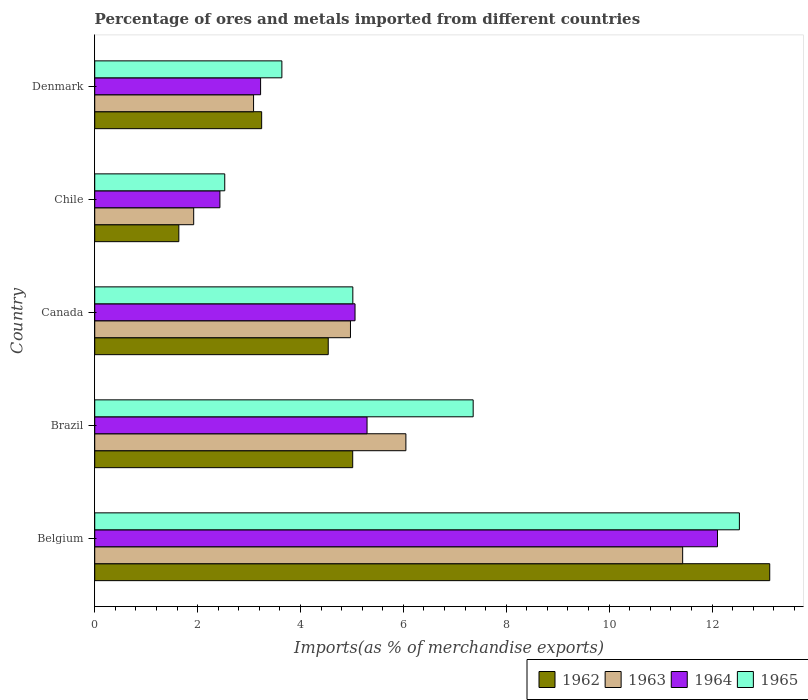How many groups of bars are there?
Ensure brevity in your answer.  5. How many bars are there on the 1st tick from the bottom?
Your answer should be compact. 4. What is the label of the 1st group of bars from the top?
Ensure brevity in your answer.  Denmark. What is the percentage of imports to different countries in 1965 in Canada?
Provide a succinct answer. 5.02. Across all countries, what is the maximum percentage of imports to different countries in 1963?
Provide a short and direct response. 11.43. Across all countries, what is the minimum percentage of imports to different countries in 1963?
Your response must be concise. 1.92. What is the total percentage of imports to different countries in 1965 in the graph?
Make the answer very short. 31.07. What is the difference between the percentage of imports to different countries in 1965 in Belgium and that in Canada?
Provide a short and direct response. 7.51. What is the difference between the percentage of imports to different countries in 1965 in Denmark and the percentage of imports to different countries in 1963 in Canada?
Keep it short and to the point. -1.33. What is the average percentage of imports to different countries in 1962 per country?
Offer a terse response. 5.51. What is the difference between the percentage of imports to different countries in 1963 and percentage of imports to different countries in 1964 in Belgium?
Provide a short and direct response. -0.68. In how many countries, is the percentage of imports to different countries in 1963 greater than 6.4 %?
Offer a terse response. 1. What is the ratio of the percentage of imports to different countries in 1962 in Brazil to that in Chile?
Provide a succinct answer. 3.07. Is the percentage of imports to different countries in 1962 in Canada less than that in Denmark?
Give a very brief answer. No. Is the difference between the percentage of imports to different countries in 1963 in Belgium and Denmark greater than the difference between the percentage of imports to different countries in 1964 in Belgium and Denmark?
Offer a very short reply. No. What is the difference between the highest and the second highest percentage of imports to different countries in 1962?
Provide a succinct answer. 8.11. What is the difference between the highest and the lowest percentage of imports to different countries in 1964?
Provide a short and direct response. 9.67. Is the sum of the percentage of imports to different countries in 1965 in Canada and Chile greater than the maximum percentage of imports to different countries in 1962 across all countries?
Keep it short and to the point. No. What does the 4th bar from the top in Denmark represents?
Your answer should be compact. 1962. What does the 3rd bar from the bottom in Chile represents?
Your response must be concise. 1964. Are all the bars in the graph horizontal?
Provide a succinct answer. Yes. How many countries are there in the graph?
Offer a terse response. 5. What is the difference between two consecutive major ticks on the X-axis?
Offer a terse response. 2. Are the values on the major ticks of X-axis written in scientific E-notation?
Your answer should be compact. No. Does the graph contain any zero values?
Give a very brief answer. No. Does the graph contain grids?
Provide a short and direct response. No. How are the legend labels stacked?
Your answer should be very brief. Horizontal. What is the title of the graph?
Your answer should be compact. Percentage of ores and metals imported from different countries. Does "2002" appear as one of the legend labels in the graph?
Give a very brief answer. No. What is the label or title of the X-axis?
Give a very brief answer. Imports(as % of merchandise exports). What is the Imports(as % of merchandise exports) of 1962 in Belgium?
Ensure brevity in your answer.  13.12. What is the Imports(as % of merchandise exports) in 1963 in Belgium?
Your answer should be very brief. 11.43. What is the Imports(as % of merchandise exports) in 1964 in Belgium?
Give a very brief answer. 12.11. What is the Imports(as % of merchandise exports) in 1965 in Belgium?
Make the answer very short. 12.53. What is the Imports(as % of merchandise exports) of 1962 in Brazil?
Make the answer very short. 5.01. What is the Imports(as % of merchandise exports) in 1963 in Brazil?
Keep it short and to the point. 6.05. What is the Imports(as % of merchandise exports) in 1964 in Brazil?
Provide a succinct answer. 5.29. What is the Imports(as % of merchandise exports) of 1965 in Brazil?
Provide a succinct answer. 7.36. What is the Imports(as % of merchandise exports) of 1962 in Canada?
Provide a short and direct response. 4.54. What is the Imports(as % of merchandise exports) of 1963 in Canada?
Provide a succinct answer. 4.97. What is the Imports(as % of merchandise exports) of 1964 in Canada?
Give a very brief answer. 5.06. What is the Imports(as % of merchandise exports) of 1965 in Canada?
Keep it short and to the point. 5.02. What is the Imports(as % of merchandise exports) in 1962 in Chile?
Ensure brevity in your answer.  1.63. What is the Imports(as % of merchandise exports) of 1963 in Chile?
Offer a very short reply. 1.92. What is the Imports(as % of merchandise exports) of 1964 in Chile?
Keep it short and to the point. 2.43. What is the Imports(as % of merchandise exports) in 1965 in Chile?
Keep it short and to the point. 2.53. What is the Imports(as % of merchandise exports) in 1962 in Denmark?
Your answer should be very brief. 3.25. What is the Imports(as % of merchandise exports) in 1963 in Denmark?
Ensure brevity in your answer.  3.09. What is the Imports(as % of merchandise exports) in 1964 in Denmark?
Give a very brief answer. 3.22. What is the Imports(as % of merchandise exports) in 1965 in Denmark?
Make the answer very short. 3.64. Across all countries, what is the maximum Imports(as % of merchandise exports) in 1962?
Your response must be concise. 13.12. Across all countries, what is the maximum Imports(as % of merchandise exports) in 1963?
Provide a short and direct response. 11.43. Across all countries, what is the maximum Imports(as % of merchandise exports) in 1964?
Your answer should be compact. 12.11. Across all countries, what is the maximum Imports(as % of merchandise exports) in 1965?
Provide a succinct answer. 12.53. Across all countries, what is the minimum Imports(as % of merchandise exports) in 1962?
Offer a terse response. 1.63. Across all countries, what is the minimum Imports(as % of merchandise exports) of 1963?
Give a very brief answer. 1.92. Across all countries, what is the minimum Imports(as % of merchandise exports) in 1964?
Give a very brief answer. 2.43. Across all countries, what is the minimum Imports(as % of merchandise exports) of 1965?
Provide a succinct answer. 2.53. What is the total Imports(as % of merchandise exports) of 1962 in the graph?
Make the answer very short. 27.56. What is the total Imports(as % of merchandise exports) of 1963 in the graph?
Make the answer very short. 27.46. What is the total Imports(as % of merchandise exports) in 1964 in the graph?
Keep it short and to the point. 28.12. What is the total Imports(as % of merchandise exports) in 1965 in the graph?
Your answer should be very brief. 31.07. What is the difference between the Imports(as % of merchandise exports) of 1962 in Belgium and that in Brazil?
Your response must be concise. 8.11. What is the difference between the Imports(as % of merchandise exports) in 1963 in Belgium and that in Brazil?
Provide a short and direct response. 5.38. What is the difference between the Imports(as % of merchandise exports) of 1964 in Belgium and that in Brazil?
Your answer should be compact. 6.81. What is the difference between the Imports(as % of merchandise exports) in 1965 in Belgium and that in Brazil?
Your answer should be compact. 5.18. What is the difference between the Imports(as % of merchandise exports) of 1962 in Belgium and that in Canada?
Offer a terse response. 8.58. What is the difference between the Imports(as % of merchandise exports) in 1963 in Belgium and that in Canada?
Make the answer very short. 6.46. What is the difference between the Imports(as % of merchandise exports) in 1964 in Belgium and that in Canada?
Give a very brief answer. 7.05. What is the difference between the Imports(as % of merchandise exports) of 1965 in Belgium and that in Canada?
Ensure brevity in your answer.  7.51. What is the difference between the Imports(as % of merchandise exports) in 1962 in Belgium and that in Chile?
Your answer should be compact. 11.49. What is the difference between the Imports(as % of merchandise exports) of 1963 in Belgium and that in Chile?
Ensure brevity in your answer.  9.51. What is the difference between the Imports(as % of merchandise exports) of 1964 in Belgium and that in Chile?
Provide a short and direct response. 9.67. What is the difference between the Imports(as % of merchandise exports) of 1965 in Belgium and that in Chile?
Keep it short and to the point. 10. What is the difference between the Imports(as % of merchandise exports) of 1962 in Belgium and that in Denmark?
Offer a very short reply. 9.88. What is the difference between the Imports(as % of merchandise exports) of 1963 in Belgium and that in Denmark?
Offer a terse response. 8.34. What is the difference between the Imports(as % of merchandise exports) of 1964 in Belgium and that in Denmark?
Your answer should be very brief. 8.88. What is the difference between the Imports(as % of merchandise exports) in 1965 in Belgium and that in Denmark?
Provide a succinct answer. 8.89. What is the difference between the Imports(as % of merchandise exports) in 1962 in Brazil and that in Canada?
Offer a terse response. 0.48. What is the difference between the Imports(as % of merchandise exports) of 1963 in Brazil and that in Canada?
Offer a terse response. 1.08. What is the difference between the Imports(as % of merchandise exports) of 1964 in Brazil and that in Canada?
Offer a terse response. 0.23. What is the difference between the Imports(as % of merchandise exports) of 1965 in Brazil and that in Canada?
Make the answer very short. 2.34. What is the difference between the Imports(as % of merchandise exports) of 1962 in Brazil and that in Chile?
Keep it short and to the point. 3.38. What is the difference between the Imports(as % of merchandise exports) of 1963 in Brazil and that in Chile?
Your answer should be compact. 4.12. What is the difference between the Imports(as % of merchandise exports) of 1964 in Brazil and that in Chile?
Offer a terse response. 2.86. What is the difference between the Imports(as % of merchandise exports) in 1965 in Brazil and that in Chile?
Offer a terse response. 4.83. What is the difference between the Imports(as % of merchandise exports) of 1962 in Brazil and that in Denmark?
Ensure brevity in your answer.  1.77. What is the difference between the Imports(as % of merchandise exports) in 1963 in Brazil and that in Denmark?
Ensure brevity in your answer.  2.96. What is the difference between the Imports(as % of merchandise exports) of 1964 in Brazil and that in Denmark?
Provide a succinct answer. 2.07. What is the difference between the Imports(as % of merchandise exports) in 1965 in Brazil and that in Denmark?
Ensure brevity in your answer.  3.72. What is the difference between the Imports(as % of merchandise exports) in 1962 in Canada and that in Chile?
Your answer should be very brief. 2.9. What is the difference between the Imports(as % of merchandise exports) of 1963 in Canada and that in Chile?
Provide a succinct answer. 3.05. What is the difference between the Imports(as % of merchandise exports) in 1964 in Canada and that in Chile?
Provide a short and direct response. 2.63. What is the difference between the Imports(as % of merchandise exports) in 1965 in Canada and that in Chile?
Make the answer very short. 2.49. What is the difference between the Imports(as % of merchandise exports) of 1962 in Canada and that in Denmark?
Provide a succinct answer. 1.29. What is the difference between the Imports(as % of merchandise exports) in 1963 in Canada and that in Denmark?
Make the answer very short. 1.88. What is the difference between the Imports(as % of merchandise exports) of 1964 in Canada and that in Denmark?
Offer a terse response. 1.84. What is the difference between the Imports(as % of merchandise exports) in 1965 in Canada and that in Denmark?
Give a very brief answer. 1.38. What is the difference between the Imports(as % of merchandise exports) of 1962 in Chile and that in Denmark?
Offer a very short reply. -1.61. What is the difference between the Imports(as % of merchandise exports) in 1963 in Chile and that in Denmark?
Give a very brief answer. -1.16. What is the difference between the Imports(as % of merchandise exports) of 1964 in Chile and that in Denmark?
Ensure brevity in your answer.  -0.79. What is the difference between the Imports(as % of merchandise exports) of 1965 in Chile and that in Denmark?
Your response must be concise. -1.11. What is the difference between the Imports(as % of merchandise exports) in 1962 in Belgium and the Imports(as % of merchandise exports) in 1963 in Brazil?
Keep it short and to the point. 7.07. What is the difference between the Imports(as % of merchandise exports) in 1962 in Belgium and the Imports(as % of merchandise exports) in 1964 in Brazil?
Offer a very short reply. 7.83. What is the difference between the Imports(as % of merchandise exports) of 1962 in Belgium and the Imports(as % of merchandise exports) of 1965 in Brazil?
Your answer should be compact. 5.77. What is the difference between the Imports(as % of merchandise exports) of 1963 in Belgium and the Imports(as % of merchandise exports) of 1964 in Brazil?
Make the answer very short. 6.14. What is the difference between the Imports(as % of merchandise exports) of 1963 in Belgium and the Imports(as % of merchandise exports) of 1965 in Brazil?
Provide a succinct answer. 4.07. What is the difference between the Imports(as % of merchandise exports) in 1964 in Belgium and the Imports(as % of merchandise exports) in 1965 in Brazil?
Offer a terse response. 4.75. What is the difference between the Imports(as % of merchandise exports) of 1962 in Belgium and the Imports(as % of merchandise exports) of 1963 in Canada?
Your answer should be compact. 8.15. What is the difference between the Imports(as % of merchandise exports) in 1962 in Belgium and the Imports(as % of merchandise exports) in 1964 in Canada?
Your answer should be compact. 8.06. What is the difference between the Imports(as % of merchandise exports) in 1962 in Belgium and the Imports(as % of merchandise exports) in 1965 in Canada?
Your answer should be very brief. 8.1. What is the difference between the Imports(as % of merchandise exports) of 1963 in Belgium and the Imports(as % of merchandise exports) of 1964 in Canada?
Provide a succinct answer. 6.37. What is the difference between the Imports(as % of merchandise exports) of 1963 in Belgium and the Imports(as % of merchandise exports) of 1965 in Canada?
Ensure brevity in your answer.  6.41. What is the difference between the Imports(as % of merchandise exports) of 1964 in Belgium and the Imports(as % of merchandise exports) of 1965 in Canada?
Keep it short and to the point. 7.09. What is the difference between the Imports(as % of merchandise exports) of 1962 in Belgium and the Imports(as % of merchandise exports) of 1963 in Chile?
Offer a terse response. 11.2. What is the difference between the Imports(as % of merchandise exports) in 1962 in Belgium and the Imports(as % of merchandise exports) in 1964 in Chile?
Ensure brevity in your answer.  10.69. What is the difference between the Imports(as % of merchandise exports) in 1962 in Belgium and the Imports(as % of merchandise exports) in 1965 in Chile?
Your answer should be compact. 10.59. What is the difference between the Imports(as % of merchandise exports) of 1963 in Belgium and the Imports(as % of merchandise exports) of 1964 in Chile?
Give a very brief answer. 9. What is the difference between the Imports(as % of merchandise exports) in 1963 in Belgium and the Imports(as % of merchandise exports) in 1965 in Chile?
Your answer should be very brief. 8.9. What is the difference between the Imports(as % of merchandise exports) of 1964 in Belgium and the Imports(as % of merchandise exports) of 1965 in Chile?
Offer a terse response. 9.58. What is the difference between the Imports(as % of merchandise exports) in 1962 in Belgium and the Imports(as % of merchandise exports) in 1963 in Denmark?
Your response must be concise. 10.03. What is the difference between the Imports(as % of merchandise exports) in 1962 in Belgium and the Imports(as % of merchandise exports) in 1964 in Denmark?
Make the answer very short. 9.9. What is the difference between the Imports(as % of merchandise exports) of 1962 in Belgium and the Imports(as % of merchandise exports) of 1965 in Denmark?
Your response must be concise. 9.48. What is the difference between the Imports(as % of merchandise exports) in 1963 in Belgium and the Imports(as % of merchandise exports) in 1964 in Denmark?
Offer a terse response. 8.21. What is the difference between the Imports(as % of merchandise exports) of 1963 in Belgium and the Imports(as % of merchandise exports) of 1965 in Denmark?
Give a very brief answer. 7.79. What is the difference between the Imports(as % of merchandise exports) of 1964 in Belgium and the Imports(as % of merchandise exports) of 1965 in Denmark?
Give a very brief answer. 8.47. What is the difference between the Imports(as % of merchandise exports) in 1962 in Brazil and the Imports(as % of merchandise exports) in 1963 in Canada?
Your answer should be compact. 0.04. What is the difference between the Imports(as % of merchandise exports) in 1962 in Brazil and the Imports(as % of merchandise exports) in 1964 in Canada?
Your answer should be compact. -0.05. What is the difference between the Imports(as % of merchandise exports) in 1962 in Brazil and the Imports(as % of merchandise exports) in 1965 in Canada?
Keep it short and to the point. -0. What is the difference between the Imports(as % of merchandise exports) of 1963 in Brazil and the Imports(as % of merchandise exports) of 1964 in Canada?
Give a very brief answer. 0.99. What is the difference between the Imports(as % of merchandise exports) of 1963 in Brazil and the Imports(as % of merchandise exports) of 1965 in Canada?
Provide a succinct answer. 1.03. What is the difference between the Imports(as % of merchandise exports) of 1964 in Brazil and the Imports(as % of merchandise exports) of 1965 in Canada?
Keep it short and to the point. 0.28. What is the difference between the Imports(as % of merchandise exports) of 1962 in Brazil and the Imports(as % of merchandise exports) of 1963 in Chile?
Your response must be concise. 3.09. What is the difference between the Imports(as % of merchandise exports) of 1962 in Brazil and the Imports(as % of merchandise exports) of 1964 in Chile?
Your response must be concise. 2.58. What is the difference between the Imports(as % of merchandise exports) of 1962 in Brazil and the Imports(as % of merchandise exports) of 1965 in Chile?
Offer a terse response. 2.49. What is the difference between the Imports(as % of merchandise exports) in 1963 in Brazil and the Imports(as % of merchandise exports) in 1964 in Chile?
Ensure brevity in your answer.  3.61. What is the difference between the Imports(as % of merchandise exports) in 1963 in Brazil and the Imports(as % of merchandise exports) in 1965 in Chile?
Offer a very short reply. 3.52. What is the difference between the Imports(as % of merchandise exports) of 1964 in Brazil and the Imports(as % of merchandise exports) of 1965 in Chile?
Offer a very short reply. 2.77. What is the difference between the Imports(as % of merchandise exports) of 1962 in Brazil and the Imports(as % of merchandise exports) of 1963 in Denmark?
Give a very brief answer. 1.93. What is the difference between the Imports(as % of merchandise exports) in 1962 in Brazil and the Imports(as % of merchandise exports) in 1964 in Denmark?
Keep it short and to the point. 1.79. What is the difference between the Imports(as % of merchandise exports) of 1962 in Brazil and the Imports(as % of merchandise exports) of 1965 in Denmark?
Keep it short and to the point. 1.38. What is the difference between the Imports(as % of merchandise exports) in 1963 in Brazil and the Imports(as % of merchandise exports) in 1964 in Denmark?
Give a very brief answer. 2.82. What is the difference between the Imports(as % of merchandise exports) of 1963 in Brazil and the Imports(as % of merchandise exports) of 1965 in Denmark?
Make the answer very short. 2.41. What is the difference between the Imports(as % of merchandise exports) of 1964 in Brazil and the Imports(as % of merchandise exports) of 1965 in Denmark?
Keep it short and to the point. 1.66. What is the difference between the Imports(as % of merchandise exports) in 1962 in Canada and the Imports(as % of merchandise exports) in 1963 in Chile?
Provide a short and direct response. 2.62. What is the difference between the Imports(as % of merchandise exports) of 1962 in Canada and the Imports(as % of merchandise exports) of 1964 in Chile?
Keep it short and to the point. 2.11. What is the difference between the Imports(as % of merchandise exports) of 1962 in Canada and the Imports(as % of merchandise exports) of 1965 in Chile?
Give a very brief answer. 2.01. What is the difference between the Imports(as % of merchandise exports) of 1963 in Canada and the Imports(as % of merchandise exports) of 1964 in Chile?
Your response must be concise. 2.54. What is the difference between the Imports(as % of merchandise exports) in 1963 in Canada and the Imports(as % of merchandise exports) in 1965 in Chile?
Your response must be concise. 2.44. What is the difference between the Imports(as % of merchandise exports) of 1964 in Canada and the Imports(as % of merchandise exports) of 1965 in Chile?
Provide a short and direct response. 2.53. What is the difference between the Imports(as % of merchandise exports) of 1962 in Canada and the Imports(as % of merchandise exports) of 1963 in Denmark?
Your answer should be compact. 1.45. What is the difference between the Imports(as % of merchandise exports) in 1962 in Canada and the Imports(as % of merchandise exports) in 1964 in Denmark?
Ensure brevity in your answer.  1.31. What is the difference between the Imports(as % of merchandise exports) of 1962 in Canada and the Imports(as % of merchandise exports) of 1965 in Denmark?
Make the answer very short. 0.9. What is the difference between the Imports(as % of merchandise exports) in 1963 in Canada and the Imports(as % of merchandise exports) in 1964 in Denmark?
Keep it short and to the point. 1.75. What is the difference between the Imports(as % of merchandise exports) of 1963 in Canada and the Imports(as % of merchandise exports) of 1965 in Denmark?
Make the answer very short. 1.33. What is the difference between the Imports(as % of merchandise exports) in 1964 in Canada and the Imports(as % of merchandise exports) in 1965 in Denmark?
Offer a terse response. 1.42. What is the difference between the Imports(as % of merchandise exports) in 1962 in Chile and the Imports(as % of merchandise exports) in 1963 in Denmark?
Make the answer very short. -1.45. What is the difference between the Imports(as % of merchandise exports) of 1962 in Chile and the Imports(as % of merchandise exports) of 1964 in Denmark?
Give a very brief answer. -1.59. What is the difference between the Imports(as % of merchandise exports) of 1962 in Chile and the Imports(as % of merchandise exports) of 1965 in Denmark?
Offer a terse response. -2. What is the difference between the Imports(as % of merchandise exports) of 1963 in Chile and the Imports(as % of merchandise exports) of 1964 in Denmark?
Your answer should be very brief. -1.3. What is the difference between the Imports(as % of merchandise exports) in 1963 in Chile and the Imports(as % of merchandise exports) in 1965 in Denmark?
Give a very brief answer. -1.71. What is the difference between the Imports(as % of merchandise exports) in 1964 in Chile and the Imports(as % of merchandise exports) in 1965 in Denmark?
Make the answer very short. -1.2. What is the average Imports(as % of merchandise exports) of 1962 per country?
Ensure brevity in your answer.  5.51. What is the average Imports(as % of merchandise exports) in 1963 per country?
Ensure brevity in your answer.  5.49. What is the average Imports(as % of merchandise exports) in 1964 per country?
Your answer should be very brief. 5.62. What is the average Imports(as % of merchandise exports) in 1965 per country?
Provide a short and direct response. 6.21. What is the difference between the Imports(as % of merchandise exports) in 1962 and Imports(as % of merchandise exports) in 1963 in Belgium?
Ensure brevity in your answer.  1.69. What is the difference between the Imports(as % of merchandise exports) of 1962 and Imports(as % of merchandise exports) of 1964 in Belgium?
Offer a very short reply. 1.02. What is the difference between the Imports(as % of merchandise exports) of 1962 and Imports(as % of merchandise exports) of 1965 in Belgium?
Your answer should be very brief. 0.59. What is the difference between the Imports(as % of merchandise exports) in 1963 and Imports(as % of merchandise exports) in 1964 in Belgium?
Give a very brief answer. -0.68. What is the difference between the Imports(as % of merchandise exports) in 1963 and Imports(as % of merchandise exports) in 1965 in Belgium?
Your response must be concise. -1.1. What is the difference between the Imports(as % of merchandise exports) in 1964 and Imports(as % of merchandise exports) in 1965 in Belgium?
Provide a succinct answer. -0.43. What is the difference between the Imports(as % of merchandise exports) of 1962 and Imports(as % of merchandise exports) of 1963 in Brazil?
Your answer should be compact. -1.03. What is the difference between the Imports(as % of merchandise exports) in 1962 and Imports(as % of merchandise exports) in 1964 in Brazil?
Your answer should be compact. -0.28. What is the difference between the Imports(as % of merchandise exports) in 1962 and Imports(as % of merchandise exports) in 1965 in Brazil?
Make the answer very short. -2.34. What is the difference between the Imports(as % of merchandise exports) in 1963 and Imports(as % of merchandise exports) in 1964 in Brazil?
Your response must be concise. 0.75. What is the difference between the Imports(as % of merchandise exports) in 1963 and Imports(as % of merchandise exports) in 1965 in Brazil?
Ensure brevity in your answer.  -1.31. What is the difference between the Imports(as % of merchandise exports) of 1964 and Imports(as % of merchandise exports) of 1965 in Brazil?
Your response must be concise. -2.06. What is the difference between the Imports(as % of merchandise exports) in 1962 and Imports(as % of merchandise exports) in 1963 in Canada?
Offer a very short reply. -0.43. What is the difference between the Imports(as % of merchandise exports) in 1962 and Imports(as % of merchandise exports) in 1964 in Canada?
Your response must be concise. -0.52. What is the difference between the Imports(as % of merchandise exports) in 1962 and Imports(as % of merchandise exports) in 1965 in Canada?
Ensure brevity in your answer.  -0.48. What is the difference between the Imports(as % of merchandise exports) of 1963 and Imports(as % of merchandise exports) of 1964 in Canada?
Provide a short and direct response. -0.09. What is the difference between the Imports(as % of merchandise exports) in 1963 and Imports(as % of merchandise exports) in 1965 in Canada?
Your answer should be very brief. -0.05. What is the difference between the Imports(as % of merchandise exports) in 1964 and Imports(as % of merchandise exports) in 1965 in Canada?
Provide a short and direct response. 0.04. What is the difference between the Imports(as % of merchandise exports) of 1962 and Imports(as % of merchandise exports) of 1963 in Chile?
Make the answer very short. -0.29. What is the difference between the Imports(as % of merchandise exports) in 1962 and Imports(as % of merchandise exports) in 1964 in Chile?
Your answer should be very brief. -0.8. What is the difference between the Imports(as % of merchandise exports) in 1962 and Imports(as % of merchandise exports) in 1965 in Chile?
Provide a short and direct response. -0.89. What is the difference between the Imports(as % of merchandise exports) in 1963 and Imports(as % of merchandise exports) in 1964 in Chile?
Provide a short and direct response. -0.51. What is the difference between the Imports(as % of merchandise exports) in 1963 and Imports(as % of merchandise exports) in 1965 in Chile?
Keep it short and to the point. -0.6. What is the difference between the Imports(as % of merchandise exports) in 1964 and Imports(as % of merchandise exports) in 1965 in Chile?
Your response must be concise. -0.09. What is the difference between the Imports(as % of merchandise exports) in 1962 and Imports(as % of merchandise exports) in 1963 in Denmark?
Your response must be concise. 0.16. What is the difference between the Imports(as % of merchandise exports) in 1962 and Imports(as % of merchandise exports) in 1964 in Denmark?
Your answer should be compact. 0.02. What is the difference between the Imports(as % of merchandise exports) in 1962 and Imports(as % of merchandise exports) in 1965 in Denmark?
Your answer should be compact. -0.39. What is the difference between the Imports(as % of merchandise exports) of 1963 and Imports(as % of merchandise exports) of 1964 in Denmark?
Offer a very short reply. -0.14. What is the difference between the Imports(as % of merchandise exports) in 1963 and Imports(as % of merchandise exports) in 1965 in Denmark?
Your answer should be very brief. -0.55. What is the difference between the Imports(as % of merchandise exports) in 1964 and Imports(as % of merchandise exports) in 1965 in Denmark?
Provide a succinct answer. -0.41. What is the ratio of the Imports(as % of merchandise exports) in 1962 in Belgium to that in Brazil?
Make the answer very short. 2.62. What is the ratio of the Imports(as % of merchandise exports) of 1963 in Belgium to that in Brazil?
Offer a very short reply. 1.89. What is the ratio of the Imports(as % of merchandise exports) in 1964 in Belgium to that in Brazil?
Your answer should be very brief. 2.29. What is the ratio of the Imports(as % of merchandise exports) in 1965 in Belgium to that in Brazil?
Offer a very short reply. 1.7. What is the ratio of the Imports(as % of merchandise exports) in 1962 in Belgium to that in Canada?
Your answer should be very brief. 2.89. What is the ratio of the Imports(as % of merchandise exports) of 1963 in Belgium to that in Canada?
Provide a succinct answer. 2.3. What is the ratio of the Imports(as % of merchandise exports) in 1964 in Belgium to that in Canada?
Provide a short and direct response. 2.39. What is the ratio of the Imports(as % of merchandise exports) of 1965 in Belgium to that in Canada?
Make the answer very short. 2.5. What is the ratio of the Imports(as % of merchandise exports) of 1962 in Belgium to that in Chile?
Provide a short and direct response. 8.03. What is the ratio of the Imports(as % of merchandise exports) in 1963 in Belgium to that in Chile?
Offer a very short reply. 5.94. What is the ratio of the Imports(as % of merchandise exports) in 1964 in Belgium to that in Chile?
Offer a terse response. 4.97. What is the ratio of the Imports(as % of merchandise exports) of 1965 in Belgium to that in Chile?
Provide a succinct answer. 4.96. What is the ratio of the Imports(as % of merchandise exports) in 1962 in Belgium to that in Denmark?
Your answer should be very brief. 4.04. What is the ratio of the Imports(as % of merchandise exports) in 1963 in Belgium to that in Denmark?
Offer a very short reply. 3.7. What is the ratio of the Imports(as % of merchandise exports) of 1964 in Belgium to that in Denmark?
Your answer should be compact. 3.75. What is the ratio of the Imports(as % of merchandise exports) of 1965 in Belgium to that in Denmark?
Offer a terse response. 3.44. What is the ratio of the Imports(as % of merchandise exports) in 1962 in Brazil to that in Canada?
Provide a short and direct response. 1.1. What is the ratio of the Imports(as % of merchandise exports) in 1963 in Brazil to that in Canada?
Your answer should be compact. 1.22. What is the ratio of the Imports(as % of merchandise exports) of 1964 in Brazil to that in Canada?
Offer a very short reply. 1.05. What is the ratio of the Imports(as % of merchandise exports) in 1965 in Brazil to that in Canada?
Keep it short and to the point. 1.47. What is the ratio of the Imports(as % of merchandise exports) in 1962 in Brazil to that in Chile?
Ensure brevity in your answer.  3.07. What is the ratio of the Imports(as % of merchandise exports) of 1963 in Brazil to that in Chile?
Your answer should be very brief. 3.14. What is the ratio of the Imports(as % of merchandise exports) of 1964 in Brazil to that in Chile?
Make the answer very short. 2.18. What is the ratio of the Imports(as % of merchandise exports) in 1965 in Brazil to that in Chile?
Ensure brevity in your answer.  2.91. What is the ratio of the Imports(as % of merchandise exports) of 1962 in Brazil to that in Denmark?
Ensure brevity in your answer.  1.55. What is the ratio of the Imports(as % of merchandise exports) of 1963 in Brazil to that in Denmark?
Your answer should be very brief. 1.96. What is the ratio of the Imports(as % of merchandise exports) in 1964 in Brazil to that in Denmark?
Ensure brevity in your answer.  1.64. What is the ratio of the Imports(as % of merchandise exports) in 1965 in Brazil to that in Denmark?
Make the answer very short. 2.02. What is the ratio of the Imports(as % of merchandise exports) of 1962 in Canada to that in Chile?
Provide a succinct answer. 2.78. What is the ratio of the Imports(as % of merchandise exports) in 1963 in Canada to that in Chile?
Give a very brief answer. 2.58. What is the ratio of the Imports(as % of merchandise exports) in 1964 in Canada to that in Chile?
Make the answer very short. 2.08. What is the ratio of the Imports(as % of merchandise exports) of 1965 in Canada to that in Chile?
Ensure brevity in your answer.  1.99. What is the ratio of the Imports(as % of merchandise exports) in 1962 in Canada to that in Denmark?
Your response must be concise. 1.4. What is the ratio of the Imports(as % of merchandise exports) of 1963 in Canada to that in Denmark?
Provide a short and direct response. 1.61. What is the ratio of the Imports(as % of merchandise exports) in 1964 in Canada to that in Denmark?
Give a very brief answer. 1.57. What is the ratio of the Imports(as % of merchandise exports) of 1965 in Canada to that in Denmark?
Your answer should be compact. 1.38. What is the ratio of the Imports(as % of merchandise exports) in 1962 in Chile to that in Denmark?
Offer a very short reply. 0.5. What is the ratio of the Imports(as % of merchandise exports) in 1963 in Chile to that in Denmark?
Keep it short and to the point. 0.62. What is the ratio of the Imports(as % of merchandise exports) of 1964 in Chile to that in Denmark?
Keep it short and to the point. 0.75. What is the ratio of the Imports(as % of merchandise exports) in 1965 in Chile to that in Denmark?
Keep it short and to the point. 0.69. What is the difference between the highest and the second highest Imports(as % of merchandise exports) in 1962?
Your response must be concise. 8.11. What is the difference between the highest and the second highest Imports(as % of merchandise exports) of 1963?
Ensure brevity in your answer.  5.38. What is the difference between the highest and the second highest Imports(as % of merchandise exports) of 1964?
Keep it short and to the point. 6.81. What is the difference between the highest and the second highest Imports(as % of merchandise exports) in 1965?
Make the answer very short. 5.18. What is the difference between the highest and the lowest Imports(as % of merchandise exports) of 1962?
Offer a terse response. 11.49. What is the difference between the highest and the lowest Imports(as % of merchandise exports) in 1963?
Your response must be concise. 9.51. What is the difference between the highest and the lowest Imports(as % of merchandise exports) in 1964?
Ensure brevity in your answer.  9.67. What is the difference between the highest and the lowest Imports(as % of merchandise exports) of 1965?
Keep it short and to the point. 10. 